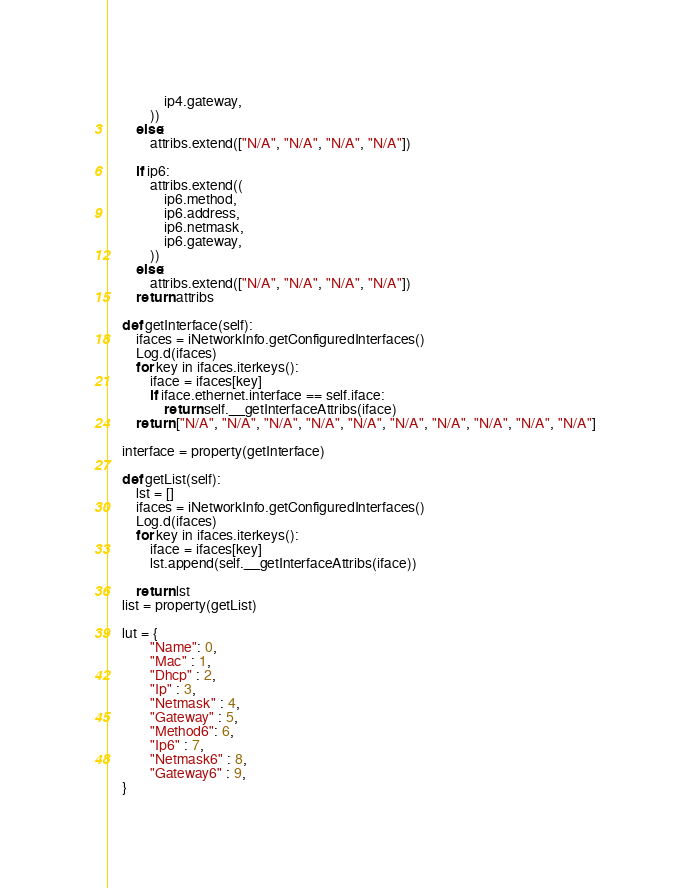<code> <loc_0><loc_0><loc_500><loc_500><_Python_>				ip4.gateway,
			))
		else:
			attribs.extend(["N/A", "N/A", "N/A", "N/A"])

		if ip6:
			attribs.extend((
				ip6.method,
				ip6.address,
				ip6.netmask,
				ip6.gateway,
			))
		else:
			attribs.extend(["N/A", "N/A", "N/A", "N/A"])
		return attribs

	def getInterface(self):
		ifaces = iNetworkInfo.getConfiguredInterfaces()
		Log.d(ifaces)
		for key in ifaces.iterkeys():
			iface = ifaces[key]
			if iface.ethernet.interface == self.iface:
				return self.__getInterfaceAttribs(iface)
		return ["N/A", "N/A", "N/A", "N/A", "N/A", "N/A", "N/A", "N/A", "N/A", "N/A"]

	interface = property(getInterface)

	def getList(self):
		lst = []
		ifaces = iNetworkInfo.getConfiguredInterfaces()
		Log.d(ifaces)
		for key in ifaces.iterkeys():
			iface = ifaces[key]
			lst.append(self.__getInterfaceAttribs(iface))

		return lst
	list = property(getList)

	lut = {
			"Name": 0,
			"Mac" : 1,
			"Dhcp" : 2,
			"Ip" : 3,
			"Netmask" : 4,
			"Gateway" : 5,
			"Method6": 6,
			"Ip6" : 7,
			"Netmask6" : 8,
			"Gateway6" : 9,
	}

</code> 